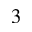Convert formula to latex. <formula><loc_0><loc_0><loc_500><loc_500>_ { 3 }</formula> 